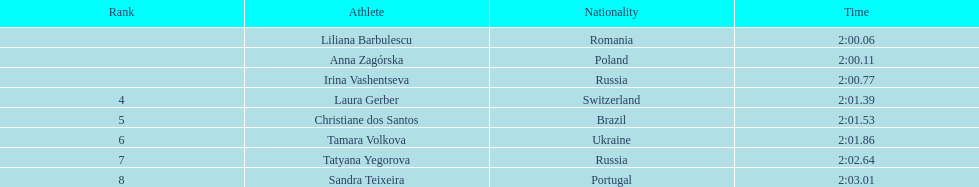How many runners finished with their time below 2:01? 3. 